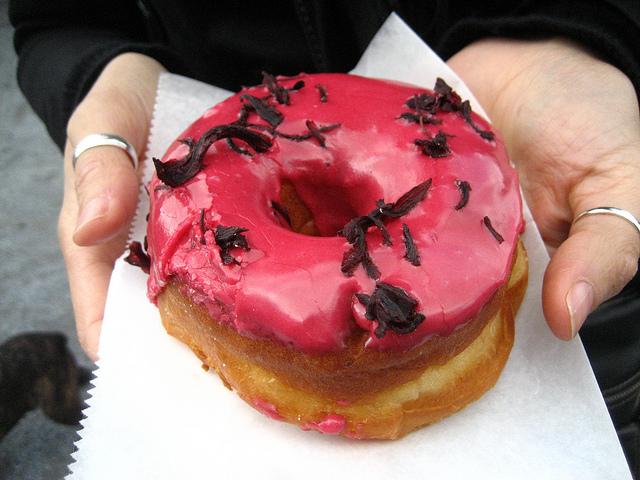What color is the glaze?
Write a very short answer. Red. What color icing is on the donut?
Concise answer only. Red. What do you call the donut topping?
Be succinct. Frosting. What is the donut on top of?
Keep it brief. Napkin. How many rings is this person holding?
Concise answer only. 2. 